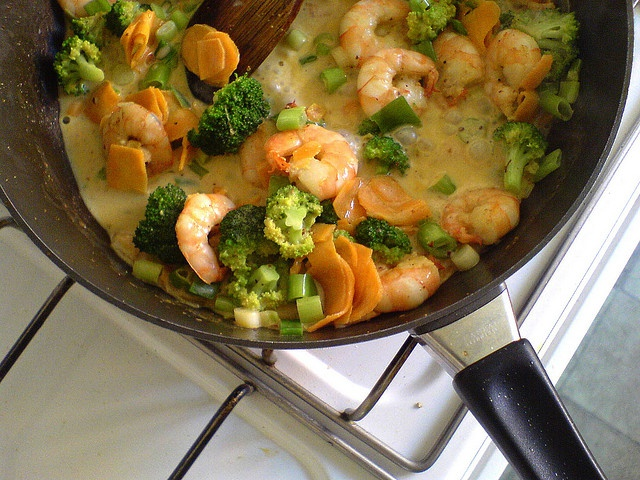Describe the objects in this image and their specific colors. I can see oven in black, olive, white, and tan tones, broccoli in black and olive tones, carrot in black, red, orange, and maroon tones, broccoli in black, darkgreen, and olive tones, and broccoli in black, olive, and darkgreen tones in this image. 